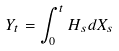<formula> <loc_0><loc_0><loc_500><loc_500>Y _ { t } = \int _ { 0 } ^ { t } H _ { s } d X _ { s }</formula> 